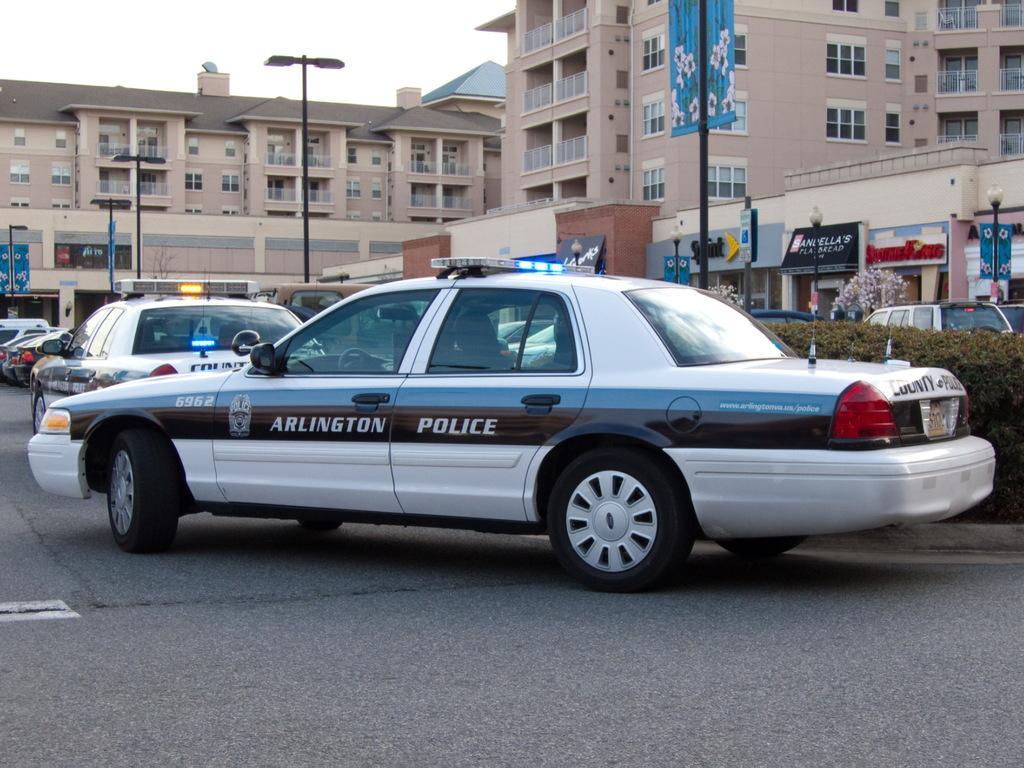Please provide a concise description of this image. In this picture I can see the police cars and other vehicles on the road. Beside that I can see the plants and lights. In the back I can see the buildings, banners, posters, trees and other objects. In the top left I can see the sky. 